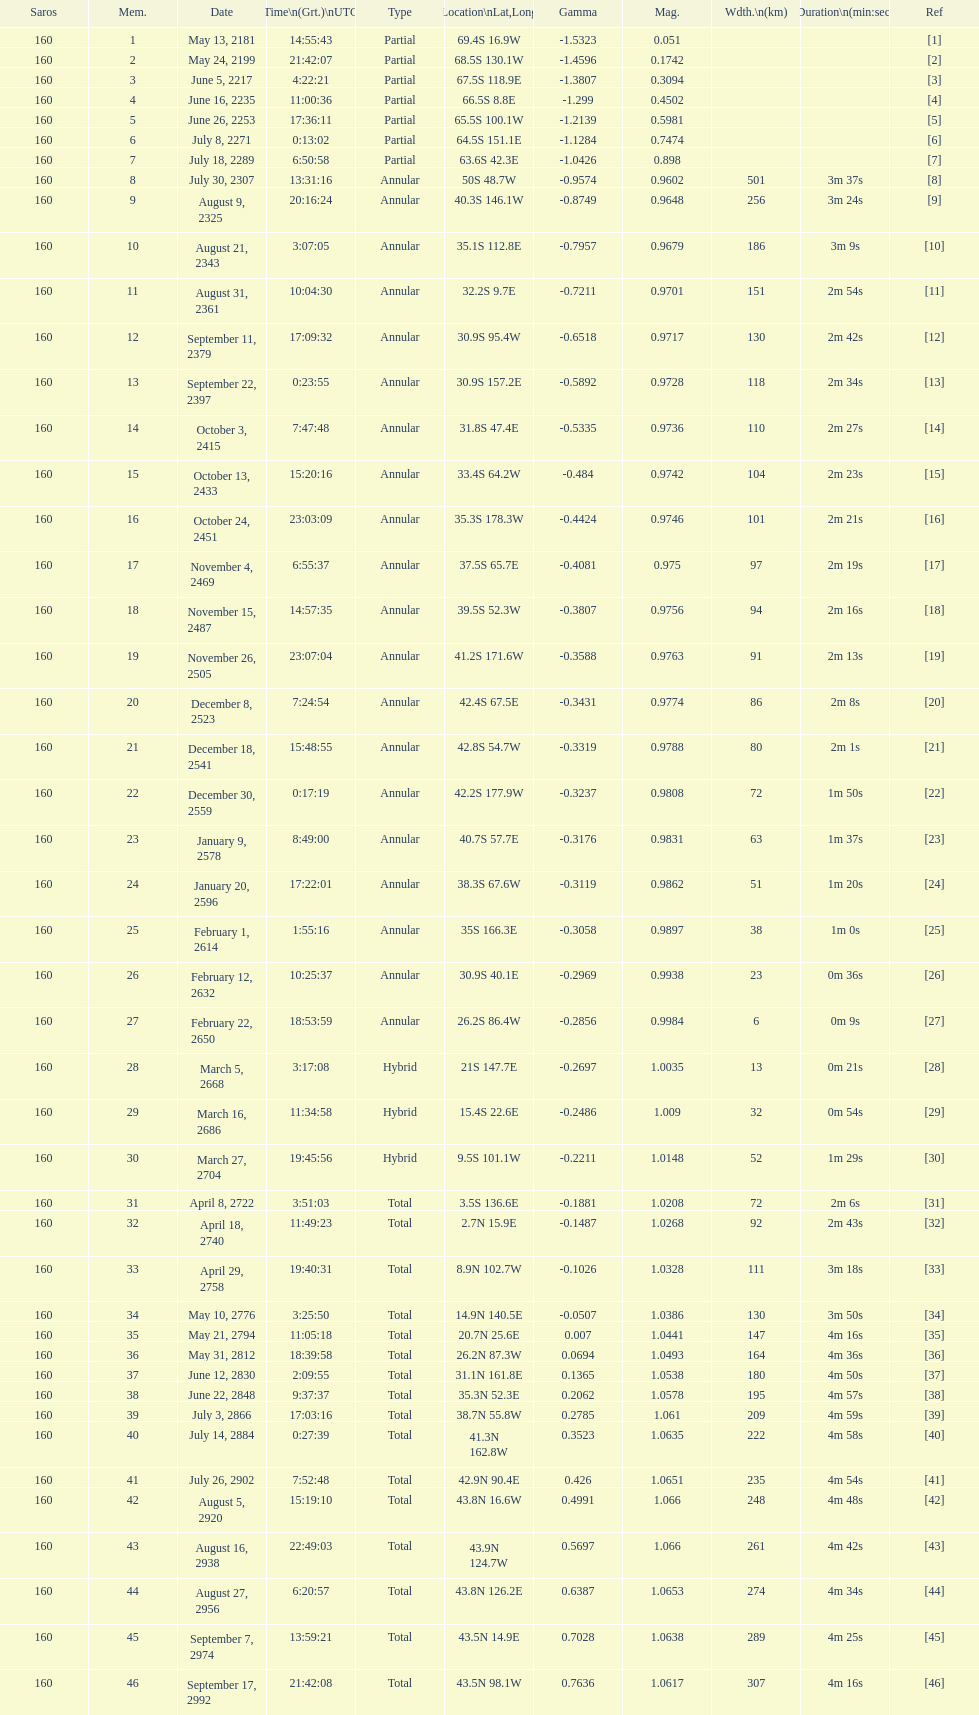Which one has a larger width, 8 or 21? 8. 